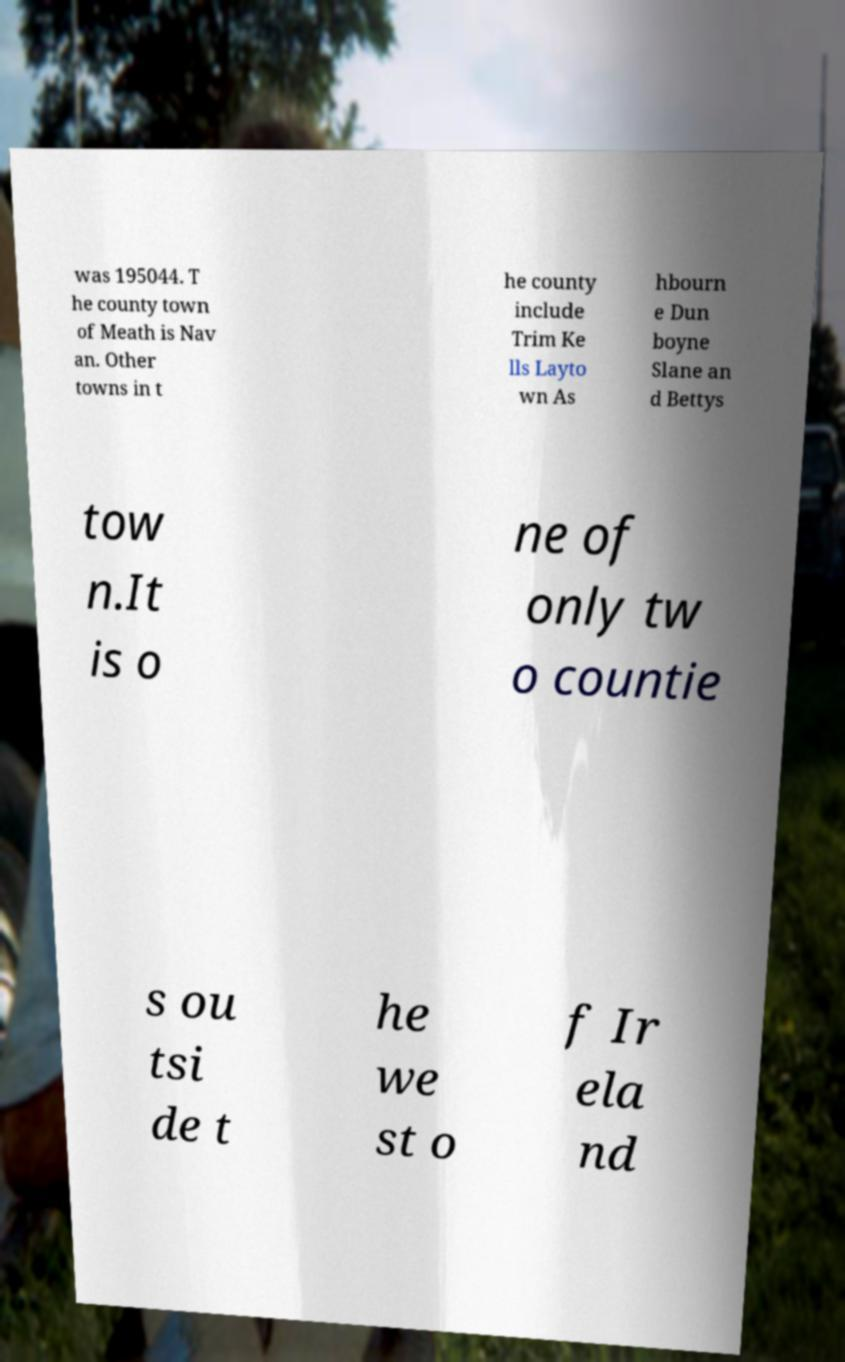Can you read and provide the text displayed in the image?This photo seems to have some interesting text. Can you extract and type it out for me? was 195044. T he county town of Meath is Nav an. Other towns in t he county include Trim Ke lls Layto wn As hbourn e Dun boyne Slane an d Bettys tow n.It is o ne of only tw o countie s ou tsi de t he we st o f Ir ela nd 